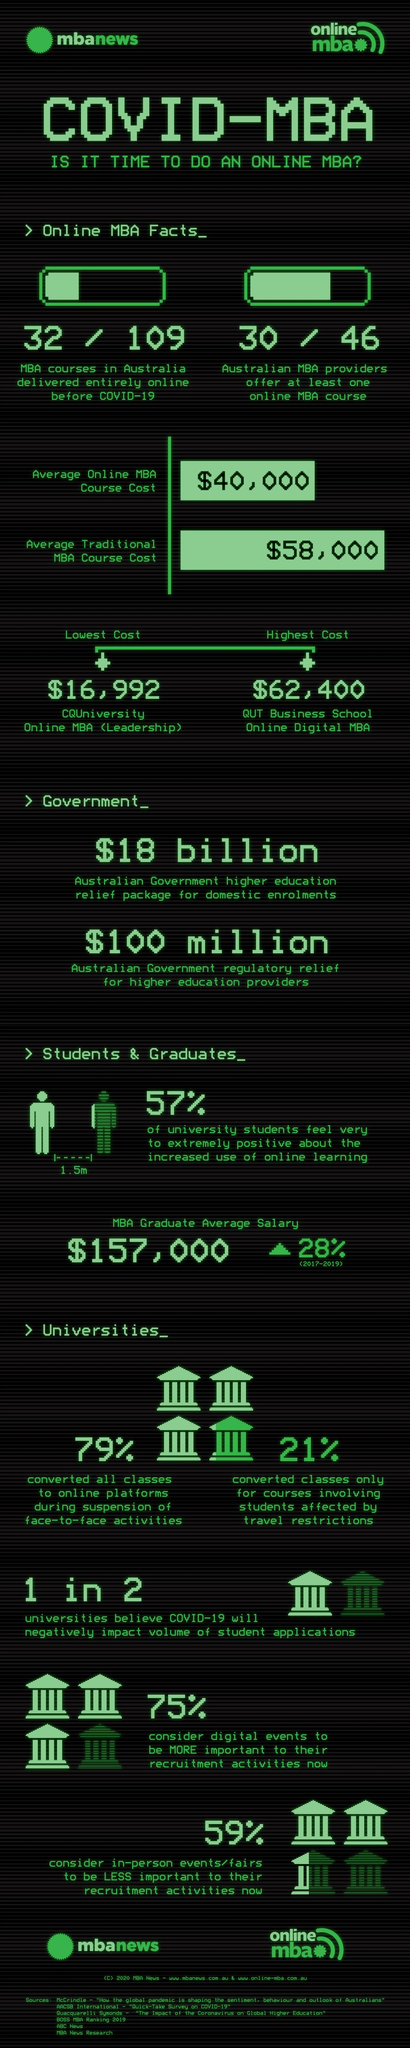List a handful of essential elements in this visual. According to the data provided, 30 out of 46 Australian MBA providers offer at least one online MBA course. Out of the 2 universities surveyed, 1 believes that Covid-19 will negatively impact the volume of student applications. Before the COVID-19 pandemic, only 77 out of 109 MBA courses in Australia were not delivered entirely online. The cost difference between the highest and lowest online MBA courses is estimated to be $45,408. 